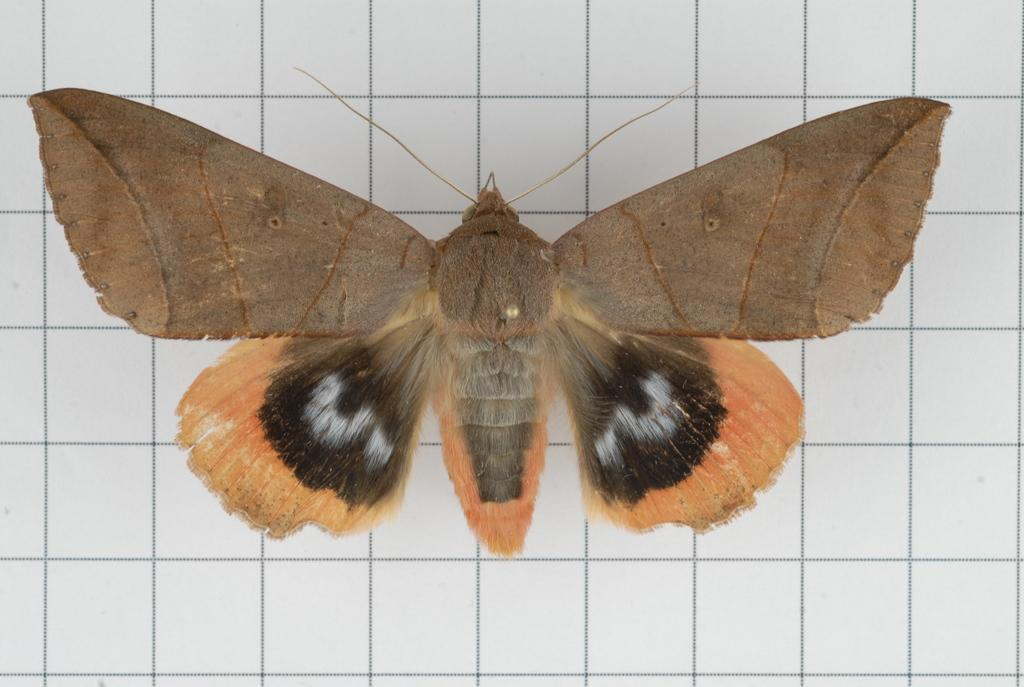What type of animal can be seen in the image? There is a butterfly in the image. What is visible in the background of the image? There is a wall in the background of the image. How many oranges are on the tray in the image? There is no tray or oranges present in the image; it features a butterfly and a wall in the background. 